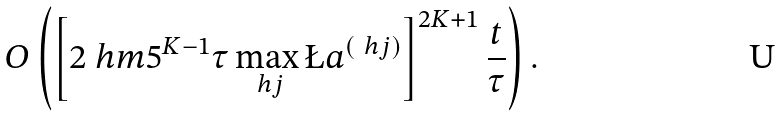Convert formula to latex. <formula><loc_0><loc_0><loc_500><loc_500>O \left ( \left [ 2 \ h m 5 ^ { K - 1 } \tau \max _ { \ h j } \L a ^ { ( \ h j ) } \right ] ^ { 2 K + 1 } \frac { t } { \tau } \right ) .</formula> 